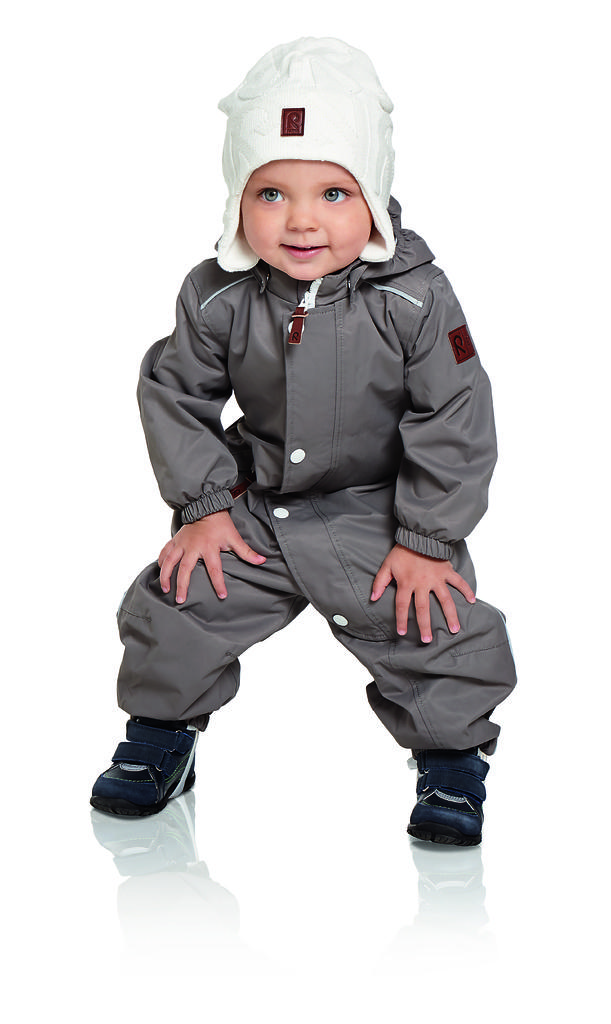What color is the dress that the person in the image is wearing? The person in the image is wearing a black dress. What type of headwear is the person wearing? The person is wearing a white cap. What color is the background of the image? The background of the image is white. What type of school does the queen attend in the image? There is no queen or school present in the image. 